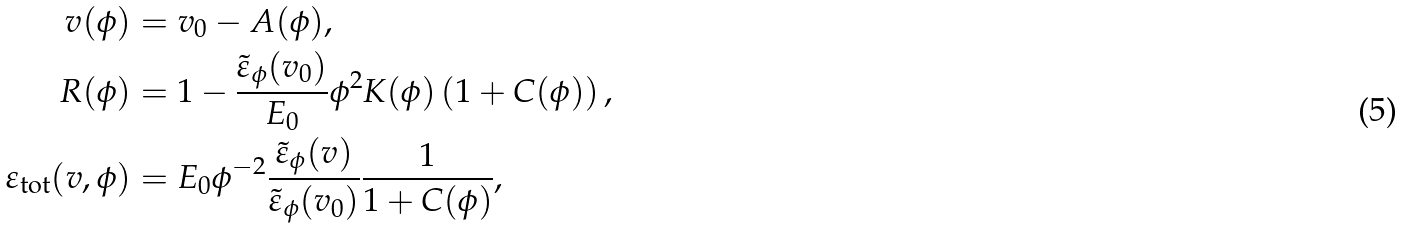Convert formula to latex. <formula><loc_0><loc_0><loc_500><loc_500>v ( \phi ) & = v _ { 0 } - A ( \phi ) , \\ R ( \phi ) & = 1 - \frac { \tilde { \varepsilon } _ { \phi } ( v _ { 0 } ) } { E _ { 0 } } \phi ^ { 2 } K ( \phi ) \left ( 1 + C ( \phi ) \right ) , \\ \varepsilon _ { \text {tot} } ( v , \phi ) & = E _ { 0 } \phi ^ { - 2 } \frac { \tilde { \varepsilon } _ { \phi } ( v ) } { \tilde { \varepsilon } _ { \phi } ( v _ { 0 } ) } \frac { 1 } { 1 + C ( \phi ) } ,</formula> 